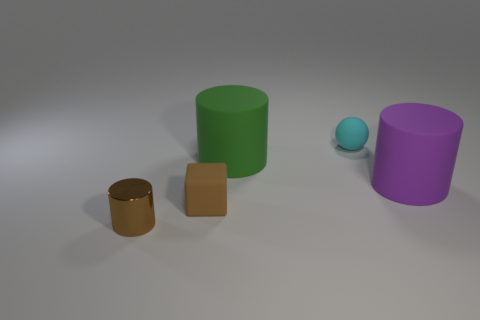Subtract all big cylinders. How many cylinders are left? 1 Subtract all blocks. How many objects are left? 4 Add 4 small yellow metallic things. How many objects exist? 9 Subtract all small cubes. Subtract all small brown matte cubes. How many objects are left? 3 Add 1 small cyan balls. How many small cyan balls are left? 2 Add 2 small cylinders. How many small cylinders exist? 3 Subtract 1 brown blocks. How many objects are left? 4 Subtract all brown cylinders. Subtract all brown blocks. How many cylinders are left? 2 